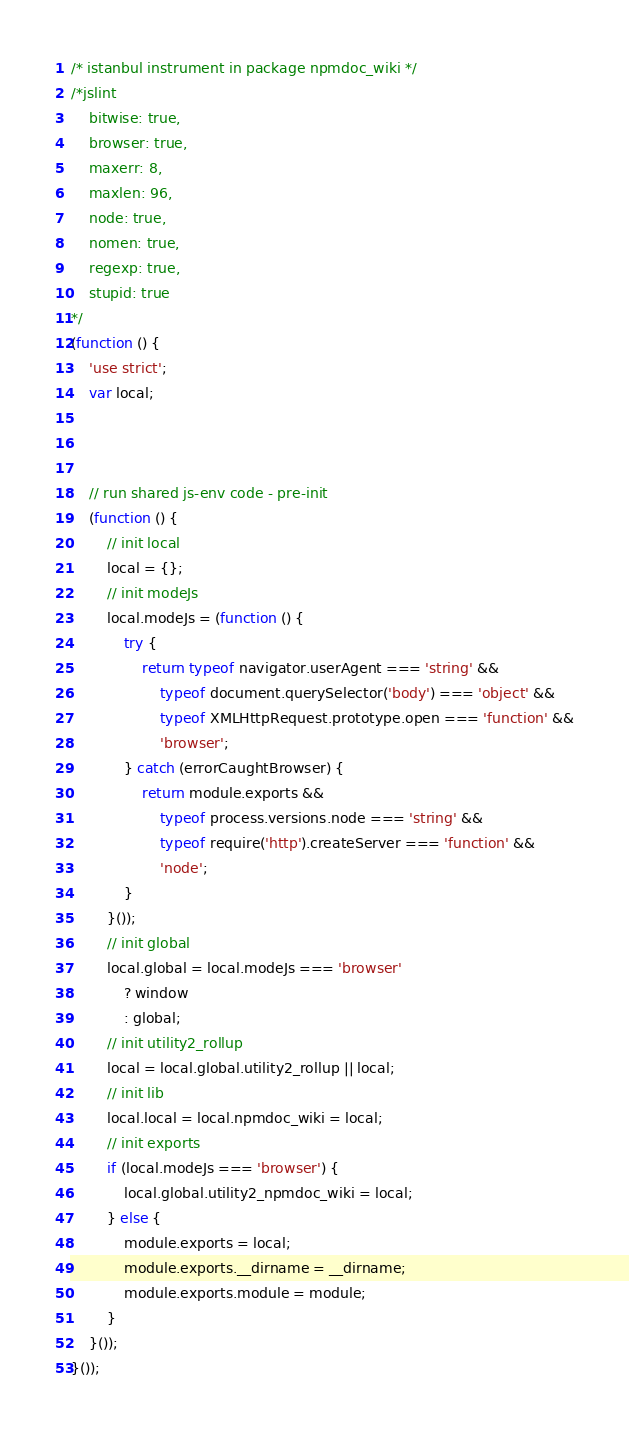<code> <loc_0><loc_0><loc_500><loc_500><_JavaScript_>/* istanbul instrument in package npmdoc_wiki */
/*jslint
    bitwise: true,
    browser: true,
    maxerr: 8,
    maxlen: 96,
    node: true,
    nomen: true,
    regexp: true,
    stupid: true
*/
(function () {
    'use strict';
    var local;



    // run shared js-env code - pre-init
    (function () {
        // init local
        local = {};
        // init modeJs
        local.modeJs = (function () {
            try {
                return typeof navigator.userAgent === 'string' &&
                    typeof document.querySelector('body') === 'object' &&
                    typeof XMLHttpRequest.prototype.open === 'function' &&
                    'browser';
            } catch (errorCaughtBrowser) {
                return module.exports &&
                    typeof process.versions.node === 'string' &&
                    typeof require('http').createServer === 'function' &&
                    'node';
            }
        }());
        // init global
        local.global = local.modeJs === 'browser'
            ? window
            : global;
        // init utility2_rollup
        local = local.global.utility2_rollup || local;
        // init lib
        local.local = local.npmdoc_wiki = local;
        // init exports
        if (local.modeJs === 'browser') {
            local.global.utility2_npmdoc_wiki = local;
        } else {
            module.exports = local;
            module.exports.__dirname = __dirname;
            module.exports.module = module;
        }
    }());
}());
</code> 